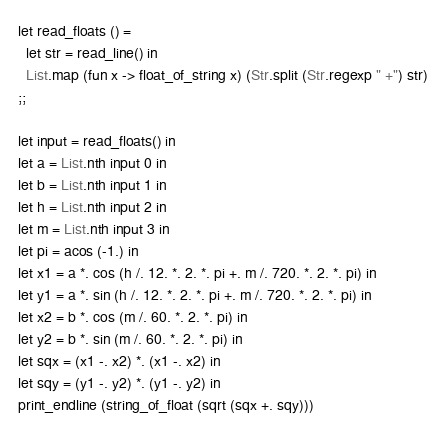Convert code to text. <code><loc_0><loc_0><loc_500><loc_500><_OCaml_>let read_floats () =
  let str = read_line() in
  List.map (fun x -> float_of_string x) (Str.split (Str.regexp " +") str)
;;

let input = read_floats() in
let a = List.nth input 0 in
let b = List.nth input 1 in
let h = List.nth input 2 in
let m = List.nth input 3 in
let pi = acos (-1.) in
let x1 = a *. cos (h /. 12. *. 2. *. pi +. m /. 720. *. 2. *. pi) in
let y1 = a *. sin (h /. 12. *. 2. *. pi +. m /. 720. *. 2. *. pi) in
let x2 = b *. cos (m /. 60. *. 2. *. pi) in
let y2 = b *. sin (m /. 60. *. 2. *. pi) in
let sqx = (x1 -. x2) *. (x1 -. x2) in
let sqy = (y1 -. y2) *. (y1 -. y2) in
print_endline (string_of_float (sqrt (sqx +. sqy)))
</code> 